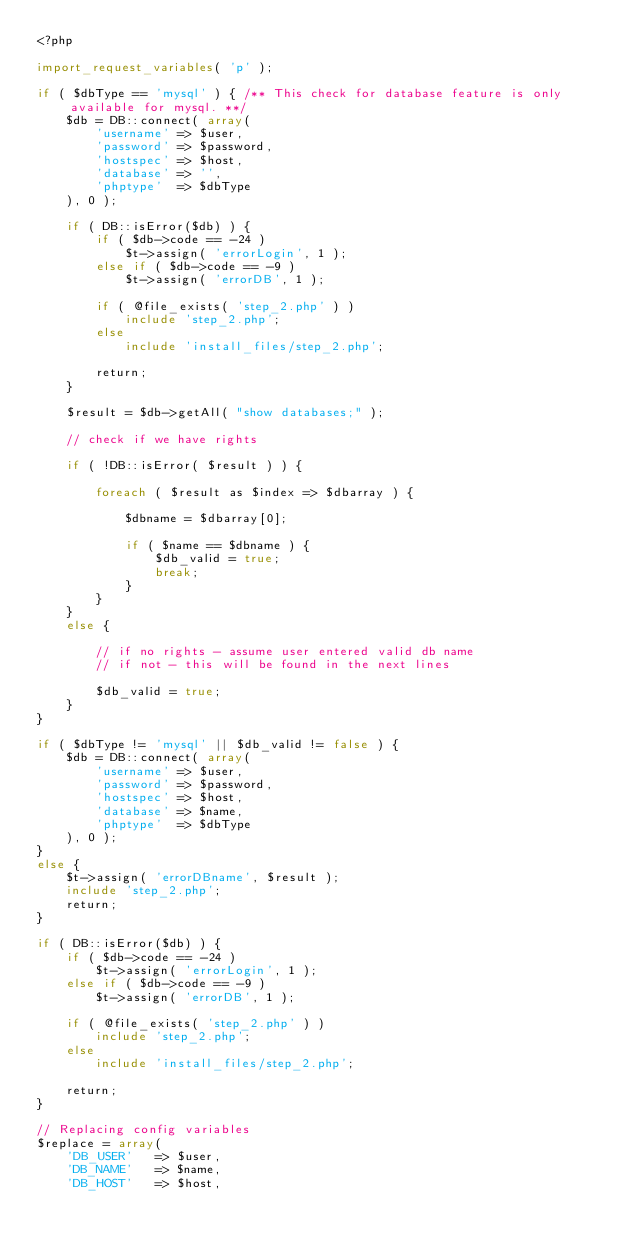<code> <loc_0><loc_0><loc_500><loc_500><_PHP_><?php

import_request_variables( 'p' );

if ( $dbType == 'mysql' ) { /** This check for database feature is only available for mysql. **/
	$db = DB::connect( array(
		'username' => $user,
		'password' => $password,
		'hostspec' => $host,
		'database' => '',
		'phptype'  => $dbType
	), 0 );

	if ( DB::isError($db) ) {
		if ( $db->code == -24 )
			$t->assign( 'errorLogin', 1 );
		else if ( $db->code == -9 )
			$t->assign( 'errorDB', 1 );

		if ( @file_exists( 'step_2.php' ) )
			include 'step_2.php';
		else
			include 'install_files/step_2.php';

		return;
	}

	$result = $db->getAll( "show databases;" );

	// check if we have rights

	if ( !DB::isError( $result ) ) {

		foreach ( $result as $index => $dbarray ) {

			$dbname = $dbarray[0];

			if ( $name == $dbname ) {
				$db_valid = true;
				break;
			}
		}
	}
	else {

		// if no rights - assume user entered valid db name
		// if not - this will be found in the next lines

		$db_valid = true;
	}
}

if ( $dbType != 'mysql' || $db_valid != false ) {
	$db = DB::connect( array(
		'username' => $user,
		'password' => $password,
		'hostspec' => $host,
		'database' => $name,
		'phptype'  => $dbType
	), 0 );
}
else {
	$t->assign( 'errorDBname', $result );
	include 'step_2.php';
	return;
}

if ( DB::isError($db) ) {
	if ( $db->code == -24 )
		$t->assign( 'errorLogin', 1 );
	else if ( $db->code == -9 )
		$t->assign( 'errorDB', 1 );

	if ( @file_exists( 'step_2.php' ) )
		include 'step_2.php';
	else
		include 'install_files/step_2.php';

	return;
}

// Replacing config variables
$replace = array(
	'DB_USER'	=> $user,
	'DB_NAME'	=> $name,
	'DB_HOST'	=> $host,</code> 